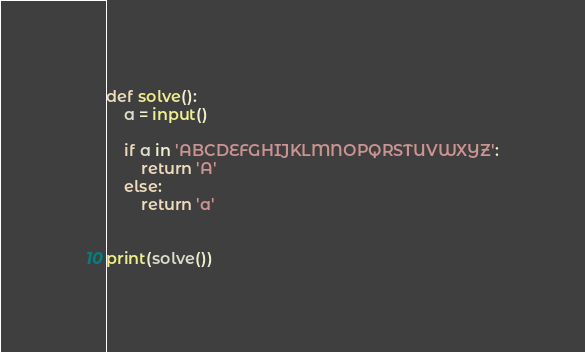<code> <loc_0><loc_0><loc_500><loc_500><_Python_>def solve():
    a = input()

    if a in 'ABCDEFGHIJKLMNOPQRSTUVWXYZ':
        return 'A'
    else:
        return 'a'


print(solve())
</code> 